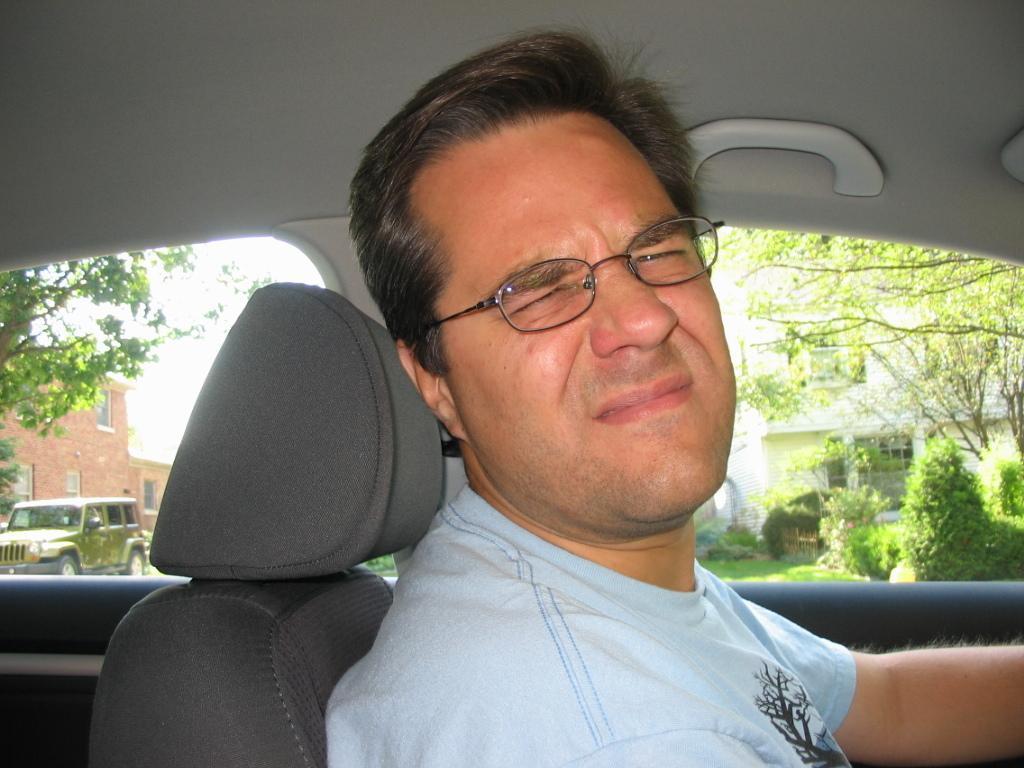Describe this image in one or two sentences. A man is sitting in his car and posing to camera with an irritating expression. 